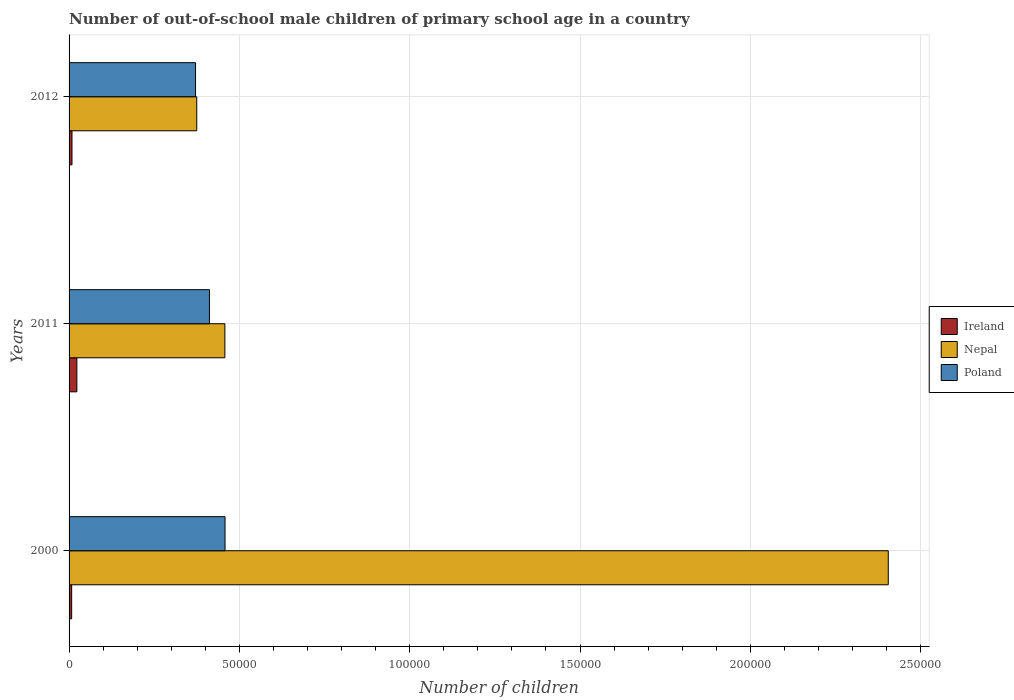How many groups of bars are there?
Your answer should be very brief. 3. Are the number of bars on each tick of the Y-axis equal?
Your answer should be very brief. Yes. How many bars are there on the 2nd tick from the top?
Your response must be concise. 3. What is the number of out-of-school male children in Poland in 2011?
Your answer should be compact. 4.12e+04. Across all years, what is the maximum number of out-of-school male children in Ireland?
Your answer should be very brief. 2292. Across all years, what is the minimum number of out-of-school male children in Ireland?
Keep it short and to the point. 761. In which year was the number of out-of-school male children in Poland minimum?
Give a very brief answer. 2012. What is the total number of out-of-school male children in Poland in the graph?
Your answer should be very brief. 1.24e+05. What is the difference between the number of out-of-school male children in Poland in 2011 and that in 2012?
Keep it short and to the point. 4083. What is the difference between the number of out-of-school male children in Ireland in 2000 and the number of out-of-school male children in Nepal in 2012?
Offer a terse response. -3.67e+04. What is the average number of out-of-school male children in Poland per year?
Provide a short and direct response. 4.14e+04. In the year 2012, what is the difference between the number of out-of-school male children in Nepal and number of out-of-school male children in Ireland?
Provide a succinct answer. 3.66e+04. What is the ratio of the number of out-of-school male children in Poland in 2011 to that in 2012?
Offer a terse response. 1.11. What is the difference between the highest and the second highest number of out-of-school male children in Ireland?
Your answer should be compact. 1435. What is the difference between the highest and the lowest number of out-of-school male children in Ireland?
Offer a very short reply. 1531. In how many years, is the number of out-of-school male children in Ireland greater than the average number of out-of-school male children in Ireland taken over all years?
Ensure brevity in your answer.  1. What does the 3rd bar from the top in 2011 represents?
Your answer should be compact. Ireland. What does the 3rd bar from the bottom in 2012 represents?
Give a very brief answer. Poland. How many bars are there?
Provide a short and direct response. 9. How many years are there in the graph?
Keep it short and to the point. 3. Are the values on the major ticks of X-axis written in scientific E-notation?
Your answer should be very brief. No. Does the graph contain grids?
Provide a short and direct response. Yes. How many legend labels are there?
Offer a terse response. 3. How are the legend labels stacked?
Offer a terse response. Vertical. What is the title of the graph?
Make the answer very short. Number of out-of-school male children of primary school age in a country. What is the label or title of the X-axis?
Ensure brevity in your answer.  Number of children. What is the label or title of the Y-axis?
Your answer should be very brief. Years. What is the Number of children in Ireland in 2000?
Provide a succinct answer. 761. What is the Number of children in Nepal in 2000?
Keep it short and to the point. 2.40e+05. What is the Number of children in Poland in 2000?
Make the answer very short. 4.58e+04. What is the Number of children in Ireland in 2011?
Your response must be concise. 2292. What is the Number of children in Nepal in 2011?
Make the answer very short. 4.57e+04. What is the Number of children in Poland in 2011?
Give a very brief answer. 4.12e+04. What is the Number of children of Ireland in 2012?
Ensure brevity in your answer.  857. What is the Number of children in Nepal in 2012?
Provide a succinct answer. 3.75e+04. What is the Number of children in Poland in 2012?
Your answer should be compact. 3.71e+04. Across all years, what is the maximum Number of children in Ireland?
Your answer should be compact. 2292. Across all years, what is the maximum Number of children in Nepal?
Provide a short and direct response. 2.40e+05. Across all years, what is the maximum Number of children in Poland?
Your answer should be compact. 4.58e+04. Across all years, what is the minimum Number of children of Ireland?
Offer a very short reply. 761. Across all years, what is the minimum Number of children in Nepal?
Keep it short and to the point. 3.75e+04. Across all years, what is the minimum Number of children of Poland?
Provide a succinct answer. 3.71e+04. What is the total Number of children of Ireland in the graph?
Your answer should be very brief. 3910. What is the total Number of children of Nepal in the graph?
Your answer should be very brief. 3.24e+05. What is the total Number of children of Poland in the graph?
Your answer should be compact. 1.24e+05. What is the difference between the Number of children in Ireland in 2000 and that in 2011?
Your answer should be compact. -1531. What is the difference between the Number of children in Nepal in 2000 and that in 2011?
Your answer should be compact. 1.95e+05. What is the difference between the Number of children of Poland in 2000 and that in 2011?
Give a very brief answer. 4574. What is the difference between the Number of children of Ireland in 2000 and that in 2012?
Your answer should be very brief. -96. What is the difference between the Number of children of Nepal in 2000 and that in 2012?
Ensure brevity in your answer.  2.03e+05. What is the difference between the Number of children of Poland in 2000 and that in 2012?
Give a very brief answer. 8657. What is the difference between the Number of children of Ireland in 2011 and that in 2012?
Give a very brief answer. 1435. What is the difference between the Number of children in Nepal in 2011 and that in 2012?
Your response must be concise. 8255. What is the difference between the Number of children of Poland in 2011 and that in 2012?
Your answer should be very brief. 4083. What is the difference between the Number of children of Ireland in 2000 and the Number of children of Nepal in 2011?
Ensure brevity in your answer.  -4.50e+04. What is the difference between the Number of children in Ireland in 2000 and the Number of children in Poland in 2011?
Ensure brevity in your answer.  -4.04e+04. What is the difference between the Number of children in Nepal in 2000 and the Number of children in Poland in 2011?
Your answer should be very brief. 1.99e+05. What is the difference between the Number of children in Ireland in 2000 and the Number of children in Nepal in 2012?
Your answer should be compact. -3.67e+04. What is the difference between the Number of children of Ireland in 2000 and the Number of children of Poland in 2012?
Give a very brief answer. -3.64e+04. What is the difference between the Number of children in Nepal in 2000 and the Number of children in Poland in 2012?
Make the answer very short. 2.03e+05. What is the difference between the Number of children of Ireland in 2011 and the Number of children of Nepal in 2012?
Ensure brevity in your answer.  -3.52e+04. What is the difference between the Number of children in Ireland in 2011 and the Number of children in Poland in 2012?
Make the answer very short. -3.48e+04. What is the difference between the Number of children in Nepal in 2011 and the Number of children in Poland in 2012?
Your answer should be compact. 8612. What is the average Number of children of Ireland per year?
Offer a very short reply. 1303.33. What is the average Number of children of Nepal per year?
Your answer should be compact. 1.08e+05. What is the average Number of children of Poland per year?
Your response must be concise. 4.14e+04. In the year 2000, what is the difference between the Number of children of Ireland and Number of children of Nepal?
Your response must be concise. -2.40e+05. In the year 2000, what is the difference between the Number of children in Ireland and Number of children in Poland?
Offer a very short reply. -4.50e+04. In the year 2000, what is the difference between the Number of children in Nepal and Number of children in Poland?
Your response must be concise. 1.95e+05. In the year 2011, what is the difference between the Number of children in Ireland and Number of children in Nepal?
Offer a terse response. -4.34e+04. In the year 2011, what is the difference between the Number of children of Ireland and Number of children of Poland?
Provide a succinct answer. -3.89e+04. In the year 2011, what is the difference between the Number of children in Nepal and Number of children in Poland?
Your answer should be compact. 4529. In the year 2012, what is the difference between the Number of children of Ireland and Number of children of Nepal?
Provide a short and direct response. -3.66e+04. In the year 2012, what is the difference between the Number of children of Ireland and Number of children of Poland?
Give a very brief answer. -3.63e+04. In the year 2012, what is the difference between the Number of children of Nepal and Number of children of Poland?
Your response must be concise. 357. What is the ratio of the Number of children of Ireland in 2000 to that in 2011?
Offer a terse response. 0.33. What is the ratio of the Number of children of Nepal in 2000 to that in 2011?
Your answer should be compact. 5.26. What is the ratio of the Number of children in Poland in 2000 to that in 2011?
Keep it short and to the point. 1.11. What is the ratio of the Number of children in Ireland in 2000 to that in 2012?
Offer a very short reply. 0.89. What is the ratio of the Number of children in Nepal in 2000 to that in 2012?
Provide a succinct answer. 6.42. What is the ratio of the Number of children in Poland in 2000 to that in 2012?
Your response must be concise. 1.23. What is the ratio of the Number of children of Ireland in 2011 to that in 2012?
Your response must be concise. 2.67. What is the ratio of the Number of children of Nepal in 2011 to that in 2012?
Your answer should be very brief. 1.22. What is the ratio of the Number of children in Poland in 2011 to that in 2012?
Provide a short and direct response. 1.11. What is the difference between the highest and the second highest Number of children of Ireland?
Ensure brevity in your answer.  1435. What is the difference between the highest and the second highest Number of children of Nepal?
Offer a terse response. 1.95e+05. What is the difference between the highest and the second highest Number of children of Poland?
Provide a succinct answer. 4574. What is the difference between the highest and the lowest Number of children in Ireland?
Provide a succinct answer. 1531. What is the difference between the highest and the lowest Number of children of Nepal?
Give a very brief answer. 2.03e+05. What is the difference between the highest and the lowest Number of children of Poland?
Provide a short and direct response. 8657. 